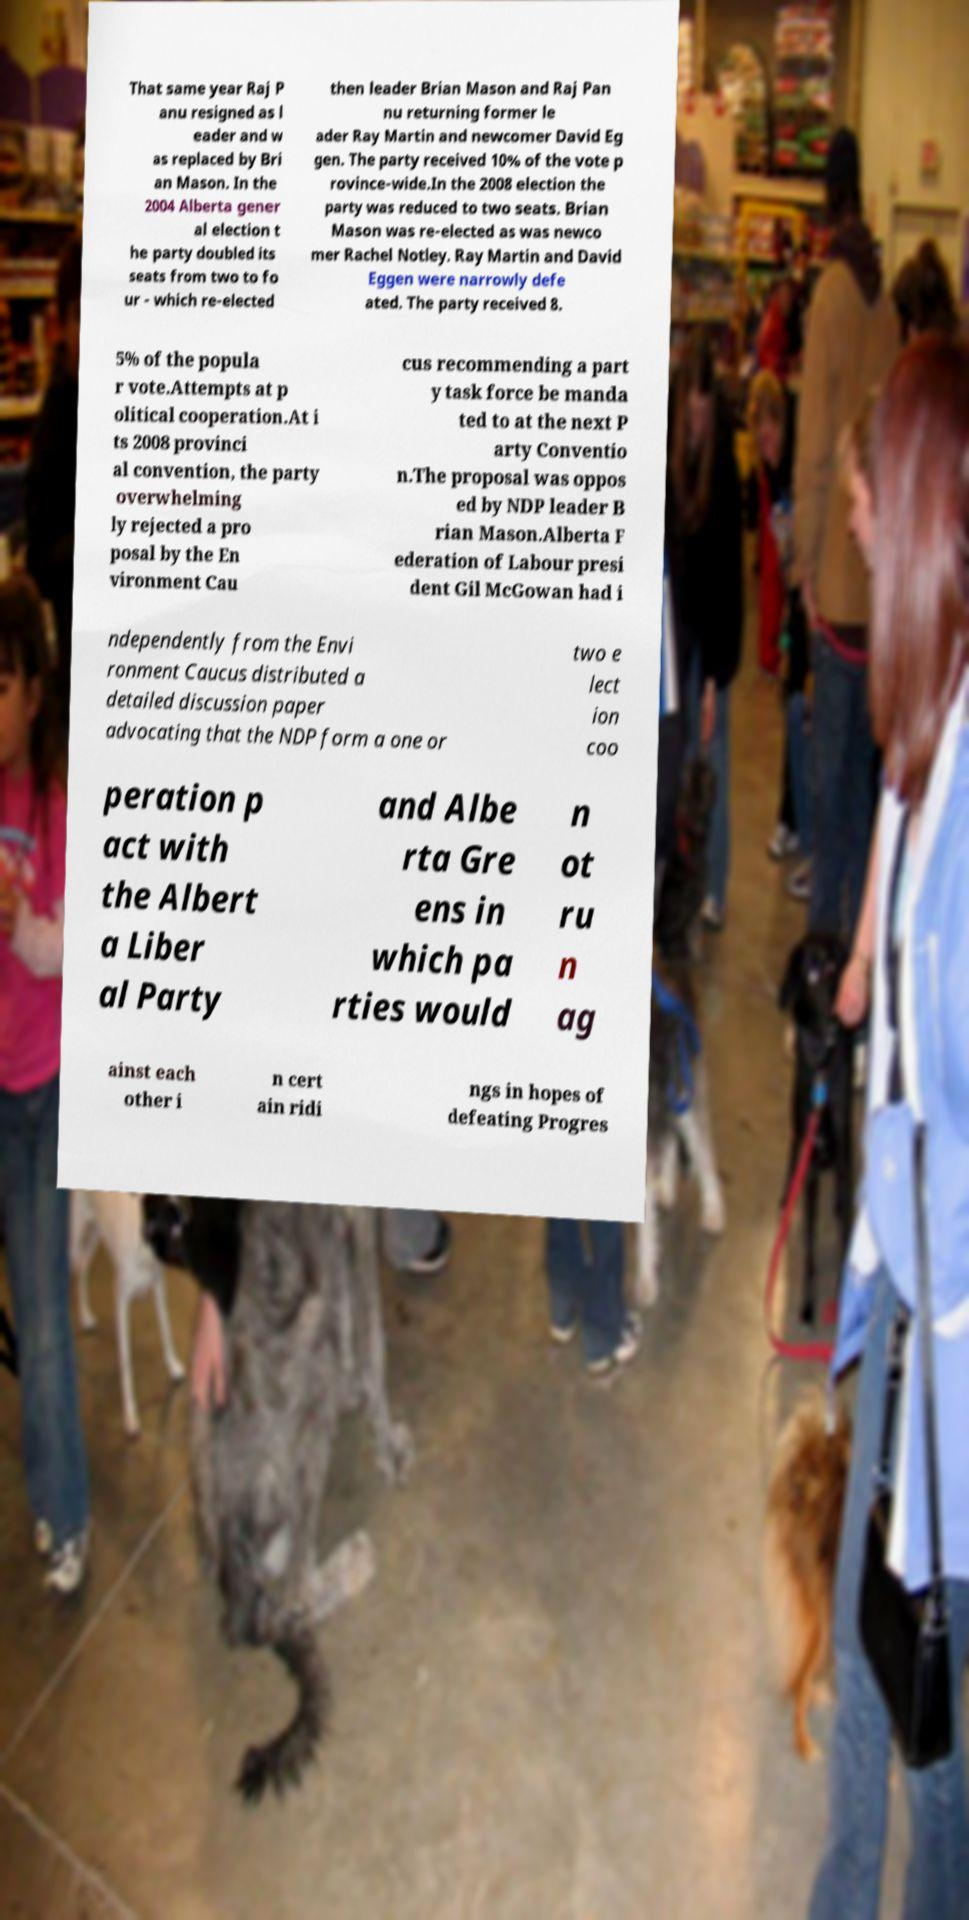Please read and relay the text visible in this image. What does it say? That same year Raj P anu resigned as l eader and w as replaced by Bri an Mason. In the 2004 Alberta gener al election t he party doubled its seats from two to fo ur - which re-elected then leader Brian Mason and Raj Pan nu returning former le ader Ray Martin and newcomer David Eg gen. The party received 10% of the vote p rovince-wide.In the 2008 election the party was reduced to two seats. Brian Mason was re-elected as was newco mer Rachel Notley. Ray Martin and David Eggen were narrowly defe ated. The party received 8. 5% of the popula r vote.Attempts at p olitical cooperation.At i ts 2008 provinci al convention, the party overwhelming ly rejected a pro posal by the En vironment Cau cus recommending a part y task force be manda ted to at the next P arty Conventio n.The proposal was oppos ed by NDP leader B rian Mason.Alberta F ederation of Labour presi dent Gil McGowan had i ndependently from the Envi ronment Caucus distributed a detailed discussion paper advocating that the NDP form a one or two e lect ion coo peration p act with the Albert a Liber al Party and Albe rta Gre ens in which pa rties would n ot ru n ag ainst each other i n cert ain ridi ngs in hopes of defeating Progres 